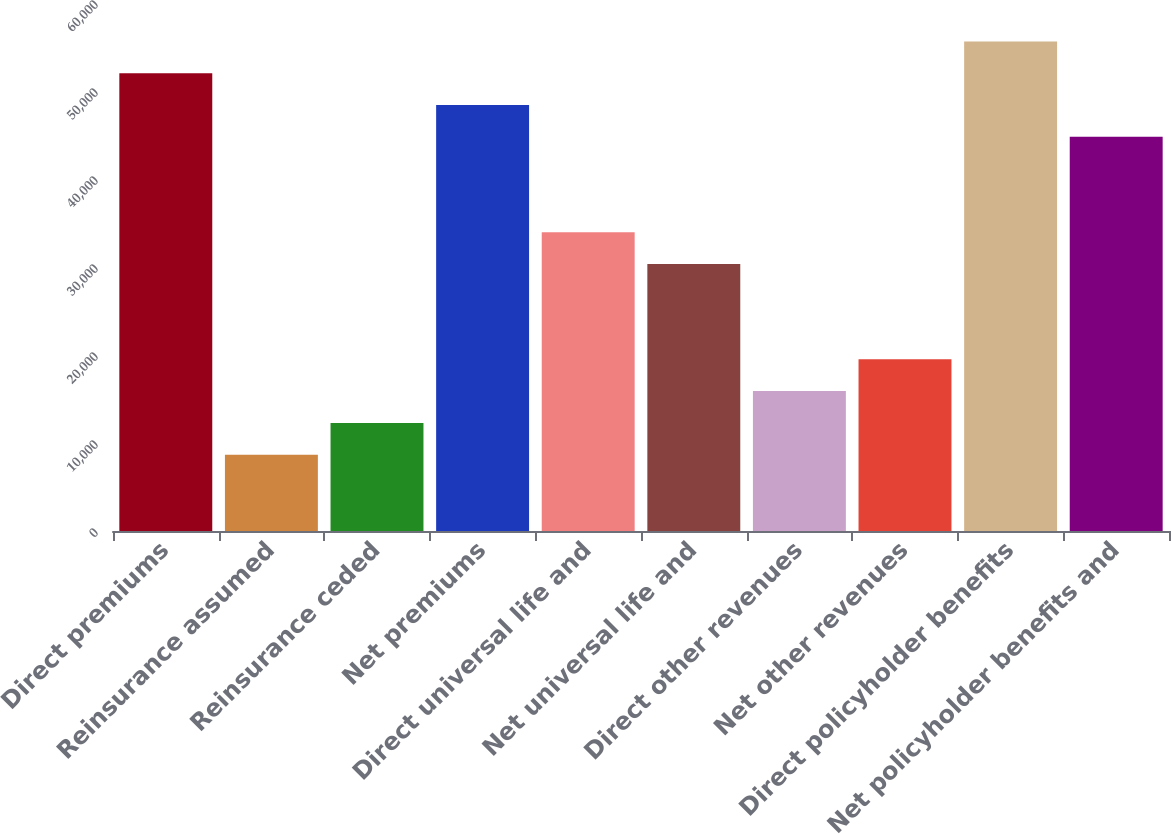Convert chart to OTSL. <chart><loc_0><loc_0><loc_500><loc_500><bar_chart><fcel>Direct premiums<fcel>Reinsurance assumed<fcel>Reinsurance ceded<fcel>Net premiums<fcel>Direct universal life and<fcel>Net universal life and<fcel>Direct other revenues<fcel>Net other revenues<fcel>Direct policyholder benefits<fcel>Net policyholder benefits and<nl><fcel>52025.2<fcel>8671.6<fcel>12284.4<fcel>48412.4<fcel>33961.2<fcel>30348.4<fcel>15897.2<fcel>19510<fcel>55638<fcel>44799.6<nl></chart> 